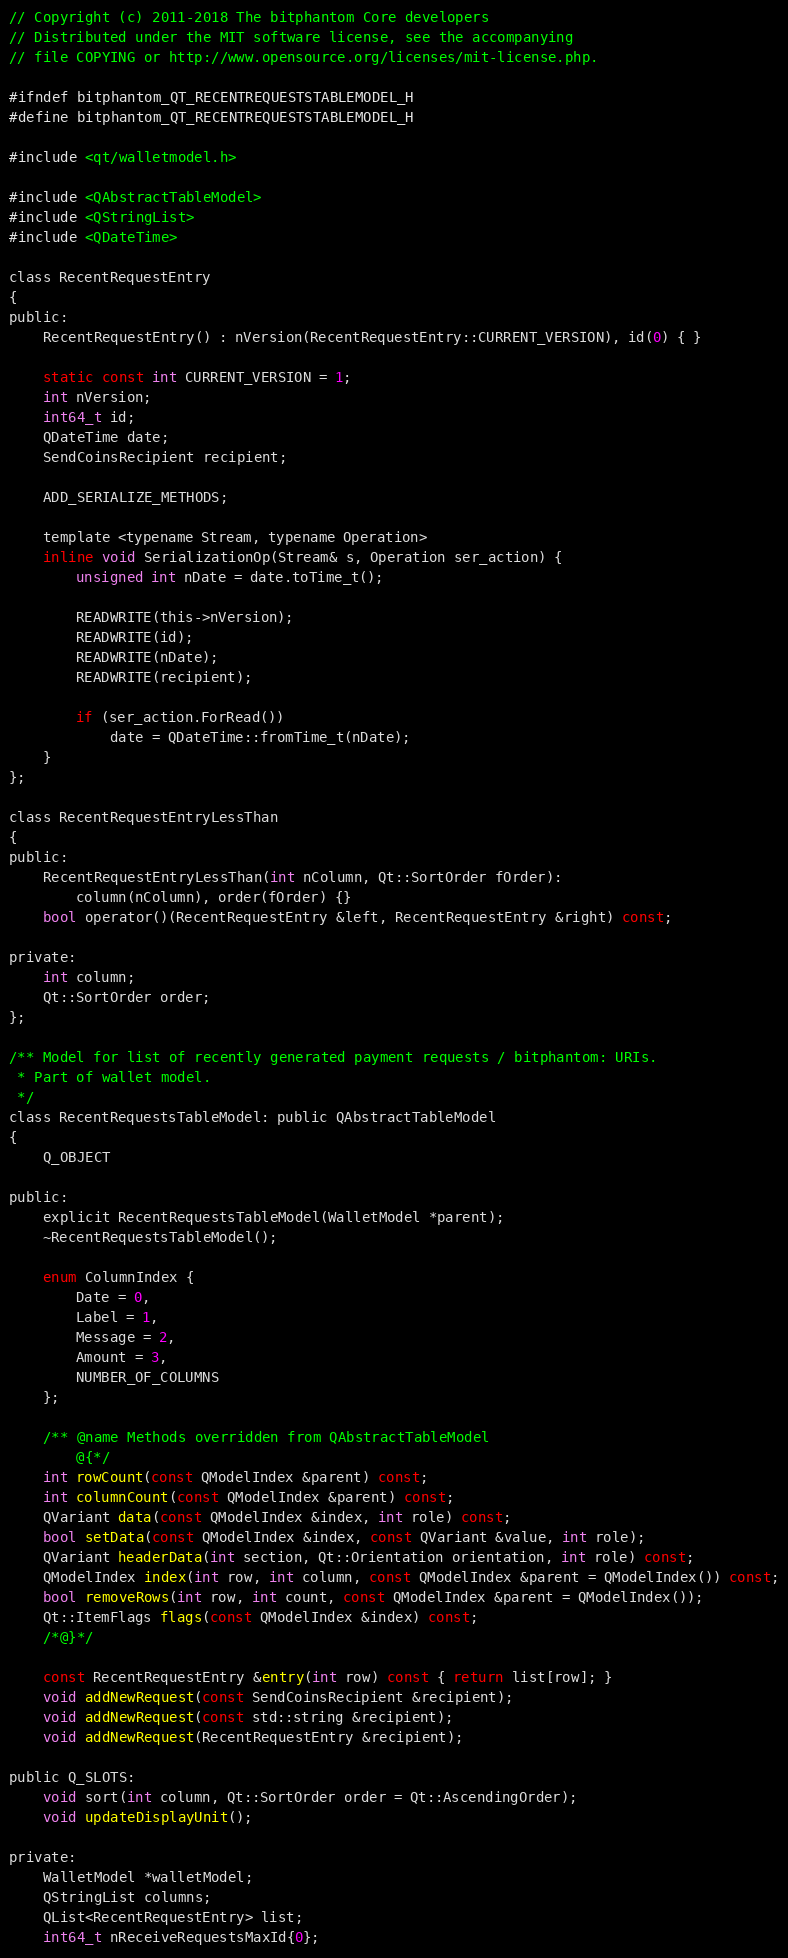<code> <loc_0><loc_0><loc_500><loc_500><_C_>// Copyright (c) 2011-2018 The bitphantom Core developers
// Distributed under the MIT software license, see the accompanying
// file COPYING or http://www.opensource.org/licenses/mit-license.php.

#ifndef bitphantom_QT_RECENTREQUESTSTABLEMODEL_H
#define bitphantom_QT_RECENTREQUESTSTABLEMODEL_H

#include <qt/walletmodel.h>

#include <QAbstractTableModel>
#include <QStringList>
#include <QDateTime>

class RecentRequestEntry
{
public:
    RecentRequestEntry() : nVersion(RecentRequestEntry::CURRENT_VERSION), id(0) { }

    static const int CURRENT_VERSION = 1;
    int nVersion;
    int64_t id;
    QDateTime date;
    SendCoinsRecipient recipient;

    ADD_SERIALIZE_METHODS;

    template <typename Stream, typename Operation>
    inline void SerializationOp(Stream& s, Operation ser_action) {
        unsigned int nDate = date.toTime_t();

        READWRITE(this->nVersion);
        READWRITE(id);
        READWRITE(nDate);
        READWRITE(recipient);

        if (ser_action.ForRead())
            date = QDateTime::fromTime_t(nDate);
    }
};

class RecentRequestEntryLessThan
{
public:
    RecentRequestEntryLessThan(int nColumn, Qt::SortOrder fOrder):
        column(nColumn), order(fOrder) {}
    bool operator()(RecentRequestEntry &left, RecentRequestEntry &right) const;

private:
    int column;
    Qt::SortOrder order;
};

/** Model for list of recently generated payment requests / bitphantom: URIs.
 * Part of wallet model.
 */
class RecentRequestsTableModel: public QAbstractTableModel
{
    Q_OBJECT

public:
    explicit RecentRequestsTableModel(WalletModel *parent);
    ~RecentRequestsTableModel();

    enum ColumnIndex {
        Date = 0,
        Label = 1,
        Message = 2,
        Amount = 3,
        NUMBER_OF_COLUMNS
    };

    /** @name Methods overridden from QAbstractTableModel
        @{*/
    int rowCount(const QModelIndex &parent) const;
    int columnCount(const QModelIndex &parent) const;
    QVariant data(const QModelIndex &index, int role) const;
    bool setData(const QModelIndex &index, const QVariant &value, int role);
    QVariant headerData(int section, Qt::Orientation orientation, int role) const;
    QModelIndex index(int row, int column, const QModelIndex &parent = QModelIndex()) const;
    bool removeRows(int row, int count, const QModelIndex &parent = QModelIndex());
    Qt::ItemFlags flags(const QModelIndex &index) const;
    /*@}*/

    const RecentRequestEntry &entry(int row) const { return list[row]; }
    void addNewRequest(const SendCoinsRecipient &recipient);
    void addNewRequest(const std::string &recipient);
    void addNewRequest(RecentRequestEntry &recipient);

public Q_SLOTS:
    void sort(int column, Qt::SortOrder order = Qt::AscendingOrder);
    void updateDisplayUnit();

private:
    WalletModel *walletModel;
    QStringList columns;
    QList<RecentRequestEntry> list;
    int64_t nReceiveRequestsMaxId{0};
</code> 